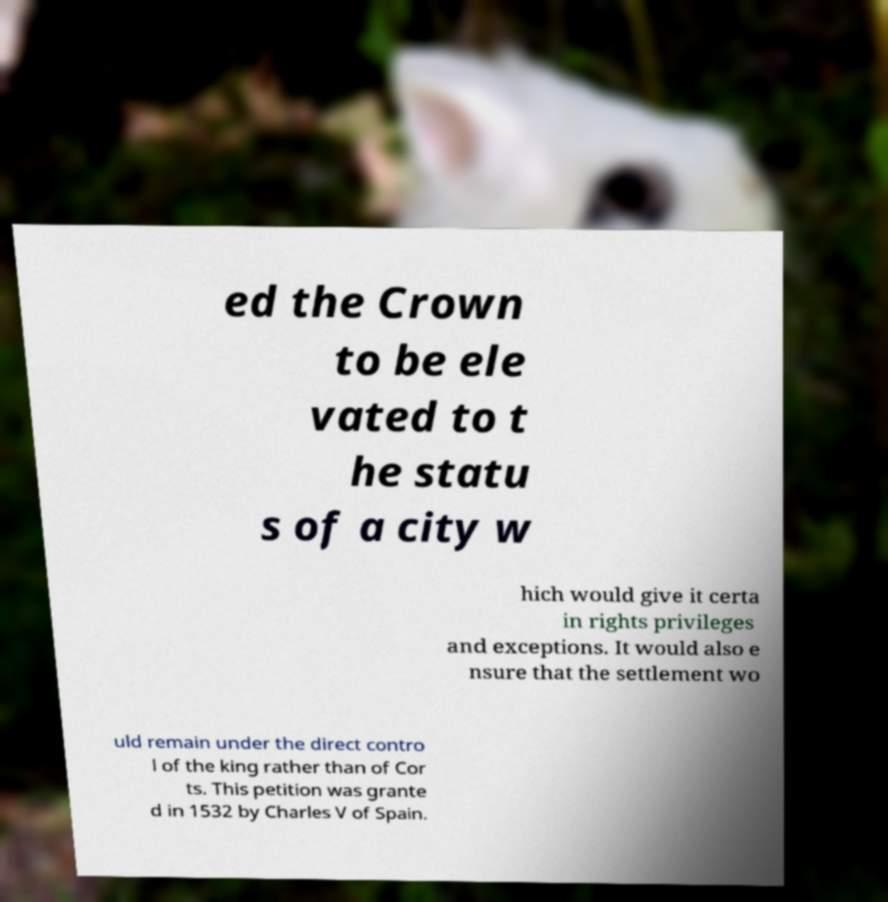There's text embedded in this image that I need extracted. Can you transcribe it verbatim? ed the Crown to be ele vated to t he statu s of a city w hich would give it certa in rights privileges and exceptions. It would also e nsure that the settlement wo uld remain under the direct contro l of the king rather than of Cor ts. This petition was grante d in 1532 by Charles V of Spain. 